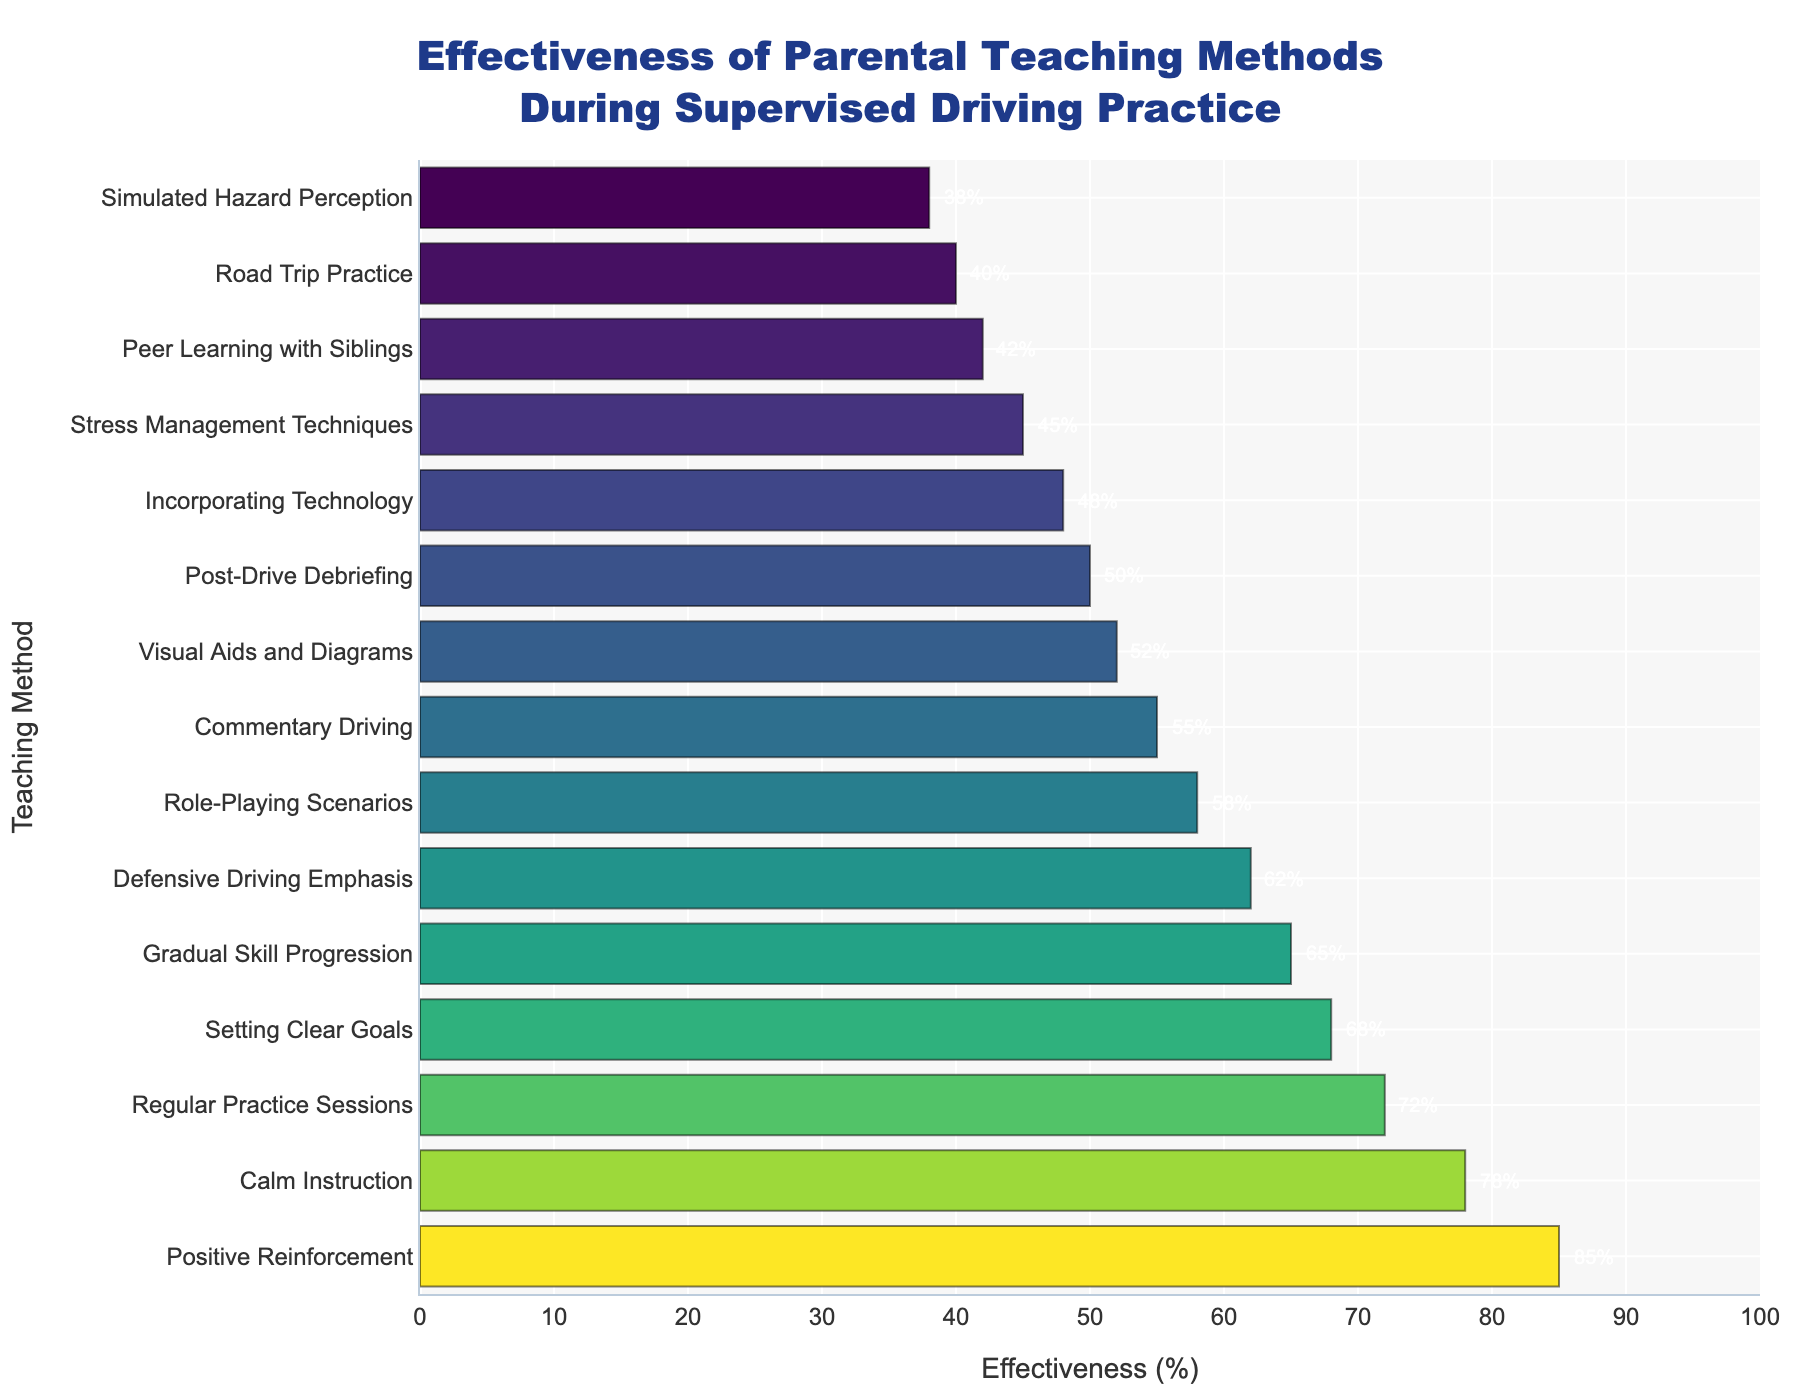Which teaching method is the most effective? The bar chart shows the effectiveness of different teaching methods, and the method with the highest effectiveness bar is "Positive Reinforcement."
Answer: Positive Reinforcement Which teaching method has the lowest effectiveness? The teaching method with the lowest bar in the chart, indicating the least effectiveness, is "Simulated Hazard Perception."
Answer: Simulated Hazard Perception What is the average effectiveness (%) of teaching methods ranked in the top five? The top five teaching methods based on effectiveness are: "Positive Reinforcement (85%)," "Calm Instruction (78%)," "Regular Practice Sessions (72%)," "Setting Clear Goals (68%)," and "Gradual Skill Progression (65%)." The average effectiveness is calculated as (85 + 78 + 72 + 68 + 65) / 5 = 368 / 5 = 73.6
Answer: 73.6 How much more effective is "Calm Instruction" compared to "Stress Management Techniques"? "Calm Instruction" has an effectiveness of 78%, while "Stress Management Techniques" has 45%. The difference is 78% - 45% = 33%.
Answer: 33% Which methods have an effectiveness of at least 50%? The methods with at least 50% effectiveness are: "Positive Reinforcement," "Calm Instruction," "Regular Practice Sessions," "Setting Clear Goals," "Gradual Skill Progression," "Defensive Driving Emphasis," "Role-Playing Scenarios," "Commentary Driving," and "Visual Aids and Diagrams."
Answer: Nine methods What is the combined effectiveness (%) of "Role-Playing Scenarios" and "Peer Learning with Siblings"? "Role-Playing Scenarios" have an effectiveness of 58%, and "Peer Learning with Siblings" have 42%. The combined effectiveness is 58% + 42% = 100%.
Answer: 100% Between "Visual Aids and Diagrams" and "Road Trip Practice," which is more effective and by how much? "Visual Aids and Diagrams" have an effectiveness of 52%, whereas "Road Trip Practice" have 40%. The difference is 52% - 40% = 12%.
Answer: Visual Aids and Diagrams by 12% Which teaching method ranks exactly in the middle in terms of effectiveness? There are 15 teaching methods in total. The middle one is the 8th when sorted by effectiveness, which is "Commentary Driving" with 55%.
Answer: Commentary Driving Are there any methods with exactly double the effectiveness of "Simulated Hazard Perception"? "Simulated Hazard Perception" has an effectiveness of 38%. Double this value is 76%. The closest method is "Calm Instruction" with 78% effectiveness, but it's not exact.
Answer: No What is the difference in effectiveness between the method with the highest effectiveness and the method with the lowest? The method with the highest effectiveness is "Positive Reinforcement" at 85%, and the lowest is "Simulated Hazard Perception" at 38%. The difference is 85% - 38% = 47%.
Answer: 47% 